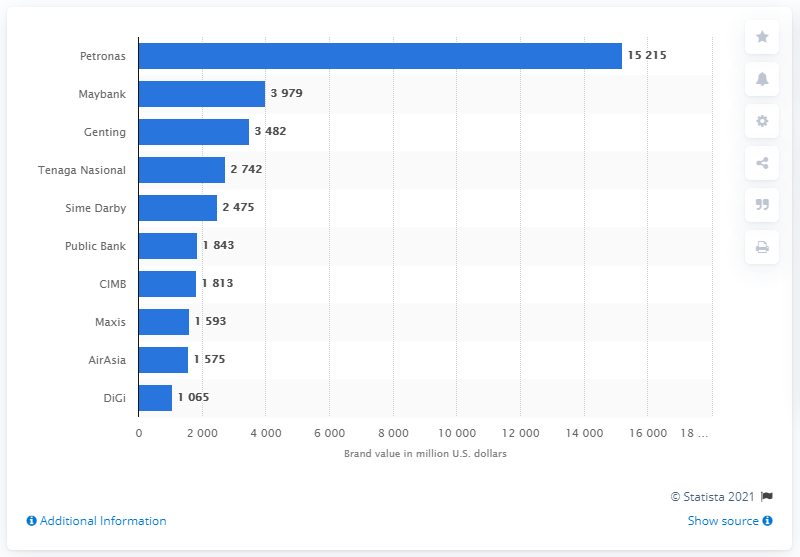What is the second most valuable Malaysian brand? Maybank is the second most valuable Malaysian brand, with a brand value of approximately 3.979 billion U.S. dollars, according to the graph displayed in the image. This places Maybank just behind Petronas, which leads with a significant margin in brand value. 